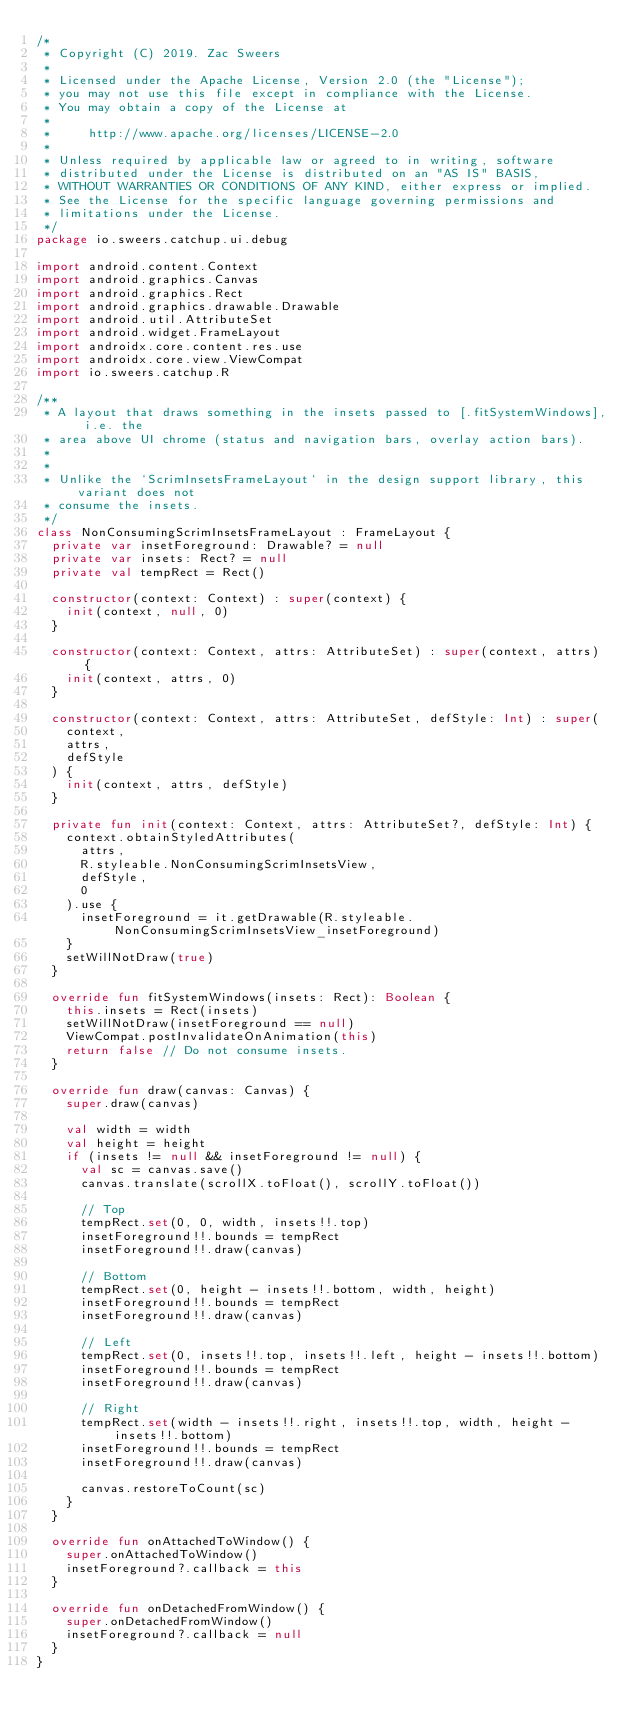Convert code to text. <code><loc_0><loc_0><loc_500><loc_500><_Kotlin_>/*
 * Copyright (C) 2019. Zac Sweers
 *
 * Licensed under the Apache License, Version 2.0 (the "License");
 * you may not use this file except in compliance with the License.
 * You may obtain a copy of the License at
 *
 *     http://www.apache.org/licenses/LICENSE-2.0
 *
 * Unless required by applicable law or agreed to in writing, software
 * distributed under the License is distributed on an "AS IS" BASIS,
 * WITHOUT WARRANTIES OR CONDITIONS OF ANY KIND, either express or implied.
 * See the License for the specific language governing permissions and
 * limitations under the License.
 */
package io.sweers.catchup.ui.debug

import android.content.Context
import android.graphics.Canvas
import android.graphics.Rect
import android.graphics.drawable.Drawable
import android.util.AttributeSet
import android.widget.FrameLayout
import androidx.core.content.res.use
import androidx.core.view.ViewCompat
import io.sweers.catchup.R

/**
 * A layout that draws something in the insets passed to [.fitSystemWindows], i.e. the
 * area above UI chrome (status and navigation bars, overlay action bars).
 *
 *
 * Unlike the `ScrimInsetsFrameLayout` in the design support library, this variant does not
 * consume the insets.
 */
class NonConsumingScrimInsetsFrameLayout : FrameLayout {
  private var insetForeground: Drawable? = null
  private var insets: Rect? = null
  private val tempRect = Rect()

  constructor(context: Context) : super(context) {
    init(context, null, 0)
  }

  constructor(context: Context, attrs: AttributeSet) : super(context, attrs) {
    init(context, attrs, 0)
  }

  constructor(context: Context, attrs: AttributeSet, defStyle: Int) : super(
    context,
    attrs,
    defStyle
  ) {
    init(context, attrs, defStyle)
  }

  private fun init(context: Context, attrs: AttributeSet?, defStyle: Int) {
    context.obtainStyledAttributes(
      attrs,
      R.styleable.NonConsumingScrimInsetsView,
      defStyle,
      0
    ).use {
      insetForeground = it.getDrawable(R.styleable.NonConsumingScrimInsetsView_insetForeground)
    }
    setWillNotDraw(true)
  }

  override fun fitSystemWindows(insets: Rect): Boolean {
    this.insets = Rect(insets)
    setWillNotDraw(insetForeground == null)
    ViewCompat.postInvalidateOnAnimation(this)
    return false // Do not consume insets.
  }

  override fun draw(canvas: Canvas) {
    super.draw(canvas)

    val width = width
    val height = height
    if (insets != null && insetForeground != null) {
      val sc = canvas.save()
      canvas.translate(scrollX.toFloat(), scrollY.toFloat())

      // Top
      tempRect.set(0, 0, width, insets!!.top)
      insetForeground!!.bounds = tempRect
      insetForeground!!.draw(canvas)

      // Bottom
      tempRect.set(0, height - insets!!.bottom, width, height)
      insetForeground!!.bounds = tempRect
      insetForeground!!.draw(canvas)

      // Left
      tempRect.set(0, insets!!.top, insets!!.left, height - insets!!.bottom)
      insetForeground!!.bounds = tempRect
      insetForeground!!.draw(canvas)

      // Right
      tempRect.set(width - insets!!.right, insets!!.top, width, height - insets!!.bottom)
      insetForeground!!.bounds = tempRect
      insetForeground!!.draw(canvas)

      canvas.restoreToCount(sc)
    }
  }

  override fun onAttachedToWindow() {
    super.onAttachedToWindow()
    insetForeground?.callback = this
  }

  override fun onDetachedFromWindow() {
    super.onDetachedFromWindow()
    insetForeground?.callback = null
  }
}
</code> 